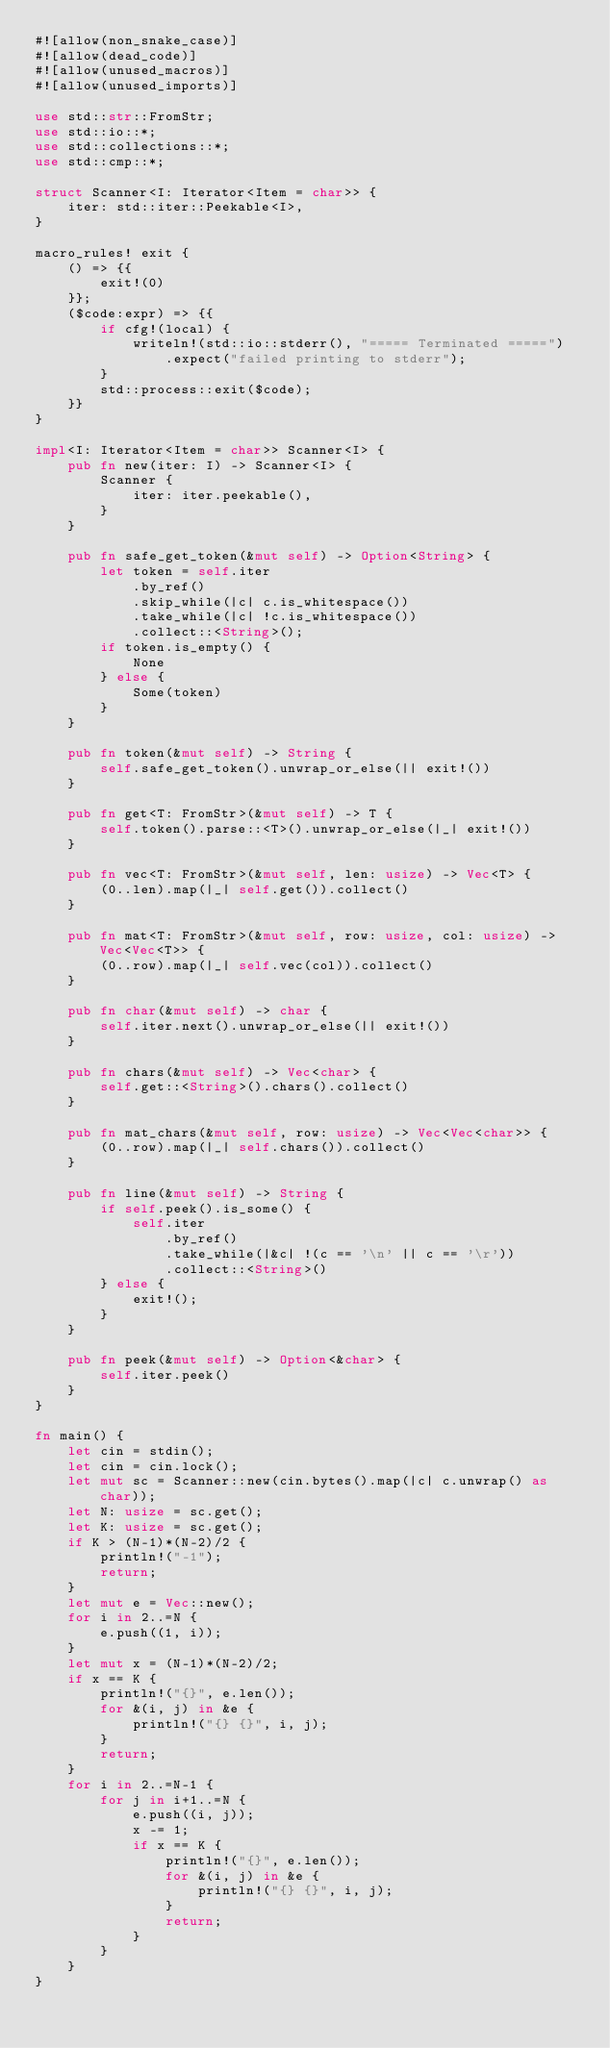<code> <loc_0><loc_0><loc_500><loc_500><_Rust_>#![allow(non_snake_case)]
#![allow(dead_code)]
#![allow(unused_macros)]
#![allow(unused_imports)]

use std::str::FromStr;
use std::io::*;
use std::collections::*;
use std::cmp::*;

struct Scanner<I: Iterator<Item = char>> {
    iter: std::iter::Peekable<I>,
}

macro_rules! exit {
    () => {{
        exit!(0)
    }};
    ($code:expr) => {{
        if cfg!(local) {
            writeln!(std::io::stderr(), "===== Terminated =====")
                .expect("failed printing to stderr");
        }
        std::process::exit($code);
    }}
}

impl<I: Iterator<Item = char>> Scanner<I> {
    pub fn new(iter: I) -> Scanner<I> {
        Scanner {
            iter: iter.peekable(),
        }
    }

    pub fn safe_get_token(&mut self) -> Option<String> {
        let token = self.iter
            .by_ref()
            .skip_while(|c| c.is_whitespace())
            .take_while(|c| !c.is_whitespace())
            .collect::<String>();
        if token.is_empty() {
            None
        } else {
            Some(token)
        }
    }

    pub fn token(&mut self) -> String {
        self.safe_get_token().unwrap_or_else(|| exit!())
    }

    pub fn get<T: FromStr>(&mut self) -> T {
        self.token().parse::<T>().unwrap_or_else(|_| exit!())
    }

    pub fn vec<T: FromStr>(&mut self, len: usize) -> Vec<T> {
        (0..len).map(|_| self.get()).collect()
    }

    pub fn mat<T: FromStr>(&mut self, row: usize, col: usize) -> Vec<Vec<T>> {
        (0..row).map(|_| self.vec(col)).collect()
    }

    pub fn char(&mut self) -> char {
        self.iter.next().unwrap_or_else(|| exit!())
    }

    pub fn chars(&mut self) -> Vec<char> {
        self.get::<String>().chars().collect()
    }

    pub fn mat_chars(&mut self, row: usize) -> Vec<Vec<char>> {
        (0..row).map(|_| self.chars()).collect()
    }

    pub fn line(&mut self) -> String {
        if self.peek().is_some() {
            self.iter
                .by_ref()
                .take_while(|&c| !(c == '\n' || c == '\r'))
                .collect::<String>()
        } else {
            exit!();
        }
    }

    pub fn peek(&mut self) -> Option<&char> {
        self.iter.peek()
    }
}

fn main() {
    let cin = stdin();
    let cin = cin.lock();
    let mut sc = Scanner::new(cin.bytes().map(|c| c.unwrap() as char));
    let N: usize = sc.get();
    let K: usize = sc.get();
    if K > (N-1)*(N-2)/2 {
        println!("-1");
        return;
    }
    let mut e = Vec::new();
    for i in 2..=N {
        e.push((1, i));
    }
    let mut x = (N-1)*(N-2)/2;
    if x == K {
        println!("{}", e.len());
        for &(i, j) in &e {
            println!("{} {}", i, j);
        }
        return;
    }
    for i in 2..=N-1 {
        for j in i+1..=N {
            e.push((i, j));
            x -= 1;
            if x == K {
                println!("{}", e.len());
                for &(i, j) in &e {
                    println!("{} {}", i, j);
                }
                return;
            }
        }
    }
}
</code> 